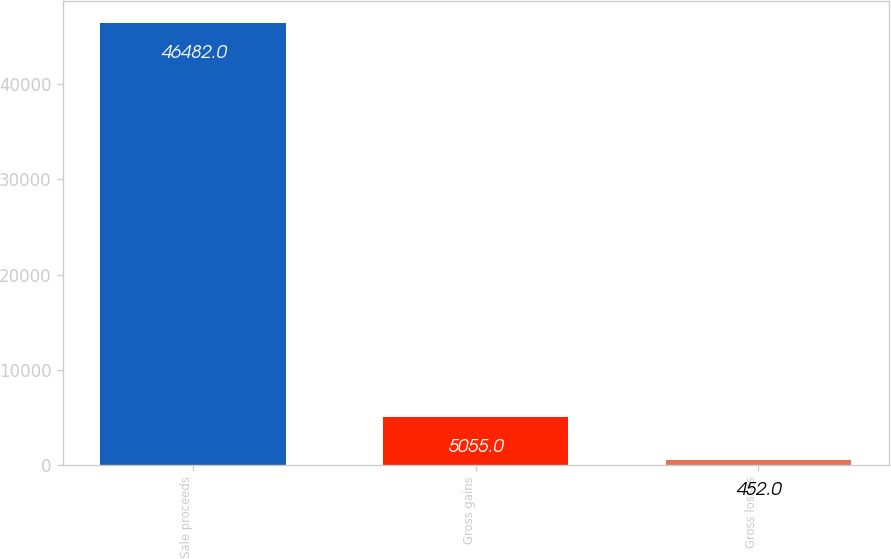Convert chart to OTSL. <chart><loc_0><loc_0><loc_500><loc_500><bar_chart><fcel>Sale proceeds<fcel>Gross gains<fcel>Gross losses<nl><fcel>46482<fcel>5055<fcel>452<nl></chart> 